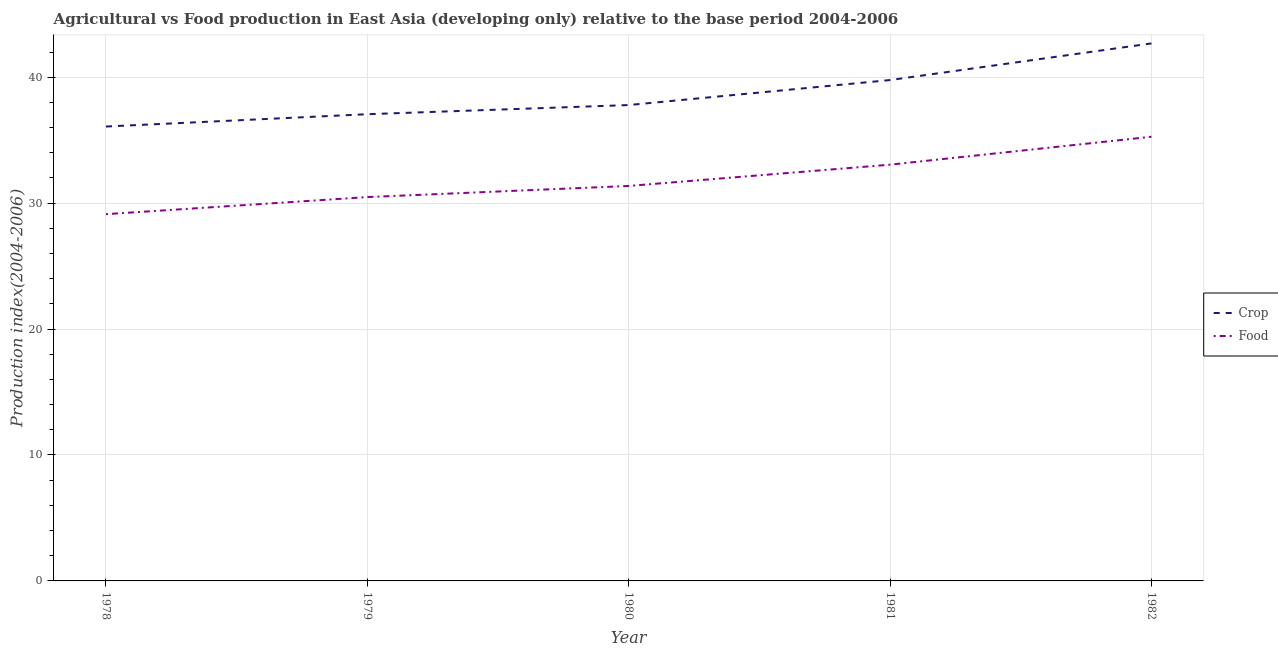How many different coloured lines are there?
Your answer should be compact. 2. Does the line corresponding to food production index intersect with the line corresponding to crop production index?
Offer a very short reply. No. What is the food production index in 1979?
Ensure brevity in your answer.  30.48. Across all years, what is the maximum food production index?
Offer a very short reply. 35.27. Across all years, what is the minimum food production index?
Give a very brief answer. 29.12. In which year was the crop production index minimum?
Offer a terse response. 1978. What is the total crop production index in the graph?
Offer a very short reply. 193.39. What is the difference between the food production index in 1981 and that in 1982?
Ensure brevity in your answer.  -2.22. What is the difference between the crop production index in 1981 and the food production index in 1982?
Offer a terse response. 4.5. What is the average food production index per year?
Provide a short and direct response. 31.86. In the year 1978, what is the difference between the food production index and crop production index?
Offer a very short reply. -6.96. What is the ratio of the food production index in 1979 to that in 1982?
Your response must be concise. 0.86. Is the crop production index in 1979 less than that in 1981?
Offer a very short reply. Yes. Is the difference between the food production index in 1979 and 1980 greater than the difference between the crop production index in 1979 and 1980?
Give a very brief answer. No. What is the difference between the highest and the second highest food production index?
Offer a very short reply. 2.22. What is the difference between the highest and the lowest crop production index?
Provide a succinct answer. 6.6. Is the sum of the crop production index in 1979 and 1982 greater than the maximum food production index across all years?
Provide a succinct answer. Yes. Does the graph contain any zero values?
Your response must be concise. No. Where does the legend appear in the graph?
Give a very brief answer. Center right. How many legend labels are there?
Offer a terse response. 2. What is the title of the graph?
Your answer should be very brief. Agricultural vs Food production in East Asia (developing only) relative to the base period 2004-2006. What is the label or title of the X-axis?
Your answer should be compact. Year. What is the label or title of the Y-axis?
Make the answer very short. Production index(2004-2006). What is the Production index(2004-2006) in Crop in 1978?
Provide a short and direct response. 36.08. What is the Production index(2004-2006) of Food in 1978?
Your answer should be very brief. 29.12. What is the Production index(2004-2006) of Crop in 1979?
Provide a short and direct response. 37.06. What is the Production index(2004-2006) of Food in 1979?
Provide a succinct answer. 30.48. What is the Production index(2004-2006) in Crop in 1980?
Your answer should be compact. 37.79. What is the Production index(2004-2006) of Food in 1980?
Your response must be concise. 31.36. What is the Production index(2004-2006) in Crop in 1981?
Offer a very short reply. 39.77. What is the Production index(2004-2006) in Food in 1981?
Ensure brevity in your answer.  33.05. What is the Production index(2004-2006) in Crop in 1982?
Make the answer very short. 42.68. What is the Production index(2004-2006) of Food in 1982?
Ensure brevity in your answer.  35.27. Across all years, what is the maximum Production index(2004-2006) in Crop?
Give a very brief answer. 42.68. Across all years, what is the maximum Production index(2004-2006) in Food?
Ensure brevity in your answer.  35.27. Across all years, what is the minimum Production index(2004-2006) in Crop?
Ensure brevity in your answer.  36.08. Across all years, what is the minimum Production index(2004-2006) in Food?
Give a very brief answer. 29.12. What is the total Production index(2004-2006) of Crop in the graph?
Offer a very short reply. 193.39. What is the total Production index(2004-2006) of Food in the graph?
Your response must be concise. 159.3. What is the difference between the Production index(2004-2006) of Crop in 1978 and that in 1979?
Provide a short and direct response. -0.98. What is the difference between the Production index(2004-2006) of Food in 1978 and that in 1979?
Offer a very short reply. -1.36. What is the difference between the Production index(2004-2006) of Crop in 1978 and that in 1980?
Your response must be concise. -1.71. What is the difference between the Production index(2004-2006) of Food in 1978 and that in 1980?
Ensure brevity in your answer.  -2.24. What is the difference between the Production index(2004-2006) of Crop in 1978 and that in 1981?
Provide a succinct answer. -3.69. What is the difference between the Production index(2004-2006) of Food in 1978 and that in 1981?
Provide a short and direct response. -3.93. What is the difference between the Production index(2004-2006) in Food in 1978 and that in 1982?
Your answer should be very brief. -6.15. What is the difference between the Production index(2004-2006) of Crop in 1979 and that in 1980?
Provide a short and direct response. -0.73. What is the difference between the Production index(2004-2006) of Food in 1979 and that in 1980?
Your response must be concise. -0.88. What is the difference between the Production index(2004-2006) of Crop in 1979 and that in 1981?
Give a very brief answer. -2.71. What is the difference between the Production index(2004-2006) of Food in 1979 and that in 1981?
Make the answer very short. -2.57. What is the difference between the Production index(2004-2006) in Crop in 1979 and that in 1982?
Your response must be concise. -5.62. What is the difference between the Production index(2004-2006) of Food in 1979 and that in 1982?
Give a very brief answer. -4.79. What is the difference between the Production index(2004-2006) in Crop in 1980 and that in 1981?
Offer a terse response. -1.99. What is the difference between the Production index(2004-2006) of Food in 1980 and that in 1981?
Your answer should be very brief. -1.69. What is the difference between the Production index(2004-2006) of Crop in 1980 and that in 1982?
Ensure brevity in your answer.  -4.89. What is the difference between the Production index(2004-2006) of Food in 1980 and that in 1982?
Give a very brief answer. -3.91. What is the difference between the Production index(2004-2006) in Crop in 1981 and that in 1982?
Offer a very short reply. -2.91. What is the difference between the Production index(2004-2006) in Food in 1981 and that in 1982?
Offer a very short reply. -2.22. What is the difference between the Production index(2004-2006) in Crop in 1978 and the Production index(2004-2006) in Food in 1979?
Keep it short and to the point. 5.6. What is the difference between the Production index(2004-2006) of Crop in 1978 and the Production index(2004-2006) of Food in 1980?
Your answer should be very brief. 4.72. What is the difference between the Production index(2004-2006) in Crop in 1978 and the Production index(2004-2006) in Food in 1981?
Ensure brevity in your answer.  3.03. What is the difference between the Production index(2004-2006) in Crop in 1978 and the Production index(2004-2006) in Food in 1982?
Keep it short and to the point. 0.81. What is the difference between the Production index(2004-2006) of Crop in 1979 and the Production index(2004-2006) of Food in 1980?
Make the answer very short. 5.7. What is the difference between the Production index(2004-2006) in Crop in 1979 and the Production index(2004-2006) in Food in 1981?
Your answer should be compact. 4.01. What is the difference between the Production index(2004-2006) of Crop in 1979 and the Production index(2004-2006) of Food in 1982?
Give a very brief answer. 1.79. What is the difference between the Production index(2004-2006) of Crop in 1980 and the Production index(2004-2006) of Food in 1981?
Offer a very short reply. 4.73. What is the difference between the Production index(2004-2006) of Crop in 1980 and the Production index(2004-2006) of Food in 1982?
Offer a very short reply. 2.52. What is the difference between the Production index(2004-2006) in Crop in 1981 and the Production index(2004-2006) in Food in 1982?
Provide a short and direct response. 4.5. What is the average Production index(2004-2006) in Crop per year?
Keep it short and to the point. 38.68. What is the average Production index(2004-2006) of Food per year?
Provide a succinct answer. 31.86. In the year 1978, what is the difference between the Production index(2004-2006) of Crop and Production index(2004-2006) of Food?
Provide a short and direct response. 6.96. In the year 1979, what is the difference between the Production index(2004-2006) of Crop and Production index(2004-2006) of Food?
Give a very brief answer. 6.58. In the year 1980, what is the difference between the Production index(2004-2006) in Crop and Production index(2004-2006) in Food?
Provide a short and direct response. 6.42. In the year 1981, what is the difference between the Production index(2004-2006) of Crop and Production index(2004-2006) of Food?
Provide a short and direct response. 6.72. In the year 1982, what is the difference between the Production index(2004-2006) in Crop and Production index(2004-2006) in Food?
Offer a very short reply. 7.41. What is the ratio of the Production index(2004-2006) in Crop in 1978 to that in 1979?
Keep it short and to the point. 0.97. What is the ratio of the Production index(2004-2006) of Food in 1978 to that in 1979?
Ensure brevity in your answer.  0.96. What is the ratio of the Production index(2004-2006) in Crop in 1978 to that in 1980?
Your answer should be very brief. 0.95. What is the ratio of the Production index(2004-2006) of Crop in 1978 to that in 1981?
Ensure brevity in your answer.  0.91. What is the ratio of the Production index(2004-2006) in Food in 1978 to that in 1981?
Offer a terse response. 0.88. What is the ratio of the Production index(2004-2006) in Crop in 1978 to that in 1982?
Give a very brief answer. 0.85. What is the ratio of the Production index(2004-2006) in Food in 1978 to that in 1982?
Your answer should be very brief. 0.83. What is the ratio of the Production index(2004-2006) in Crop in 1979 to that in 1980?
Provide a short and direct response. 0.98. What is the ratio of the Production index(2004-2006) of Food in 1979 to that in 1980?
Your answer should be very brief. 0.97. What is the ratio of the Production index(2004-2006) of Crop in 1979 to that in 1981?
Your response must be concise. 0.93. What is the ratio of the Production index(2004-2006) in Food in 1979 to that in 1981?
Your answer should be compact. 0.92. What is the ratio of the Production index(2004-2006) of Crop in 1979 to that in 1982?
Offer a terse response. 0.87. What is the ratio of the Production index(2004-2006) of Food in 1979 to that in 1982?
Keep it short and to the point. 0.86. What is the ratio of the Production index(2004-2006) of Crop in 1980 to that in 1981?
Offer a very short reply. 0.95. What is the ratio of the Production index(2004-2006) in Food in 1980 to that in 1981?
Ensure brevity in your answer.  0.95. What is the ratio of the Production index(2004-2006) in Crop in 1980 to that in 1982?
Your answer should be compact. 0.89. What is the ratio of the Production index(2004-2006) in Food in 1980 to that in 1982?
Your answer should be compact. 0.89. What is the ratio of the Production index(2004-2006) of Crop in 1981 to that in 1982?
Give a very brief answer. 0.93. What is the ratio of the Production index(2004-2006) of Food in 1981 to that in 1982?
Keep it short and to the point. 0.94. What is the difference between the highest and the second highest Production index(2004-2006) in Crop?
Offer a very short reply. 2.91. What is the difference between the highest and the second highest Production index(2004-2006) in Food?
Offer a very short reply. 2.22. What is the difference between the highest and the lowest Production index(2004-2006) in Food?
Your answer should be compact. 6.15. 